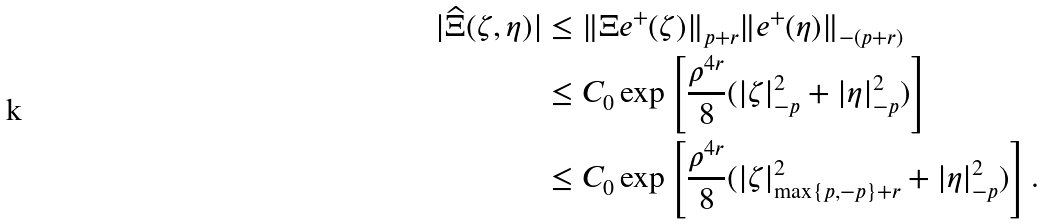Convert formula to latex. <formula><loc_0><loc_0><loc_500><loc_500>| \widehat { \Xi } ( \zeta , \eta ) | & \leq \| \Xi e ^ { + } ( \zeta ) \| _ { p + r } \| e ^ { + } ( \eta ) \| _ { - ( p + r ) } \\ & \leq C _ { 0 } \exp \left [ \frac { \rho ^ { 4 r } } { 8 } ( | \zeta | _ { - p } ^ { 2 } + | \eta | _ { - p } ^ { 2 } ) \right ] \\ & \leq C _ { 0 } \exp \left [ \frac { \rho ^ { 4 r } } { 8 } ( | \zeta | _ { \max \{ p , - p \} + r } ^ { 2 } + | \eta | _ { - p } ^ { 2 } ) \right ] .</formula> 